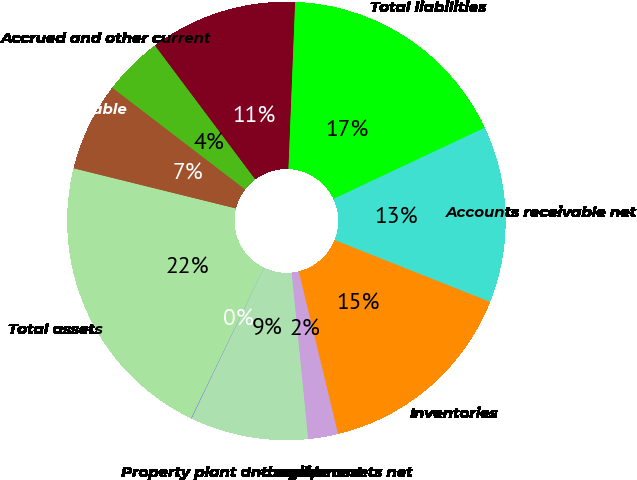Convert chart. <chart><loc_0><loc_0><loc_500><loc_500><pie_chart><fcel>Accounts receivable net<fcel>Inventories<fcel>Intangible assets net<fcel>Property plant and equipment<fcel>Other assets<fcel>Total assets<fcel>Accounts payable<fcel>Accrued and other current<fcel>Other liabilities<fcel>Total liabilities<nl><fcel>13.03%<fcel>15.19%<fcel>2.21%<fcel>8.7%<fcel>0.04%<fcel>21.69%<fcel>6.54%<fcel>4.37%<fcel>10.87%<fcel>17.36%<nl></chart> 